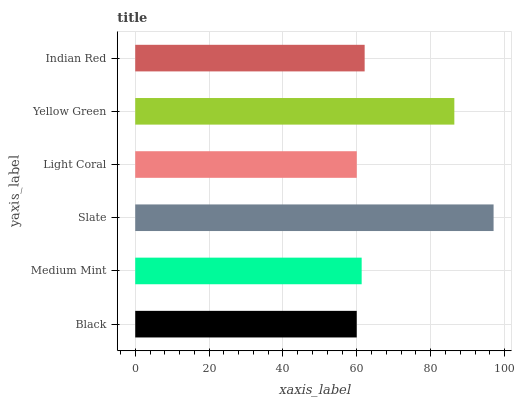Is Black the minimum?
Answer yes or no. Yes. Is Slate the maximum?
Answer yes or no. Yes. Is Medium Mint the minimum?
Answer yes or no. No. Is Medium Mint the maximum?
Answer yes or no. No. Is Medium Mint greater than Black?
Answer yes or no. Yes. Is Black less than Medium Mint?
Answer yes or no. Yes. Is Black greater than Medium Mint?
Answer yes or no. No. Is Medium Mint less than Black?
Answer yes or no. No. Is Indian Red the high median?
Answer yes or no. Yes. Is Medium Mint the low median?
Answer yes or no. Yes. Is Light Coral the high median?
Answer yes or no. No. Is Yellow Green the low median?
Answer yes or no. No. 